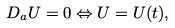<formula> <loc_0><loc_0><loc_500><loc_500>D _ { a } U = 0 \Leftrightarrow U = U ( t ) ,</formula> 